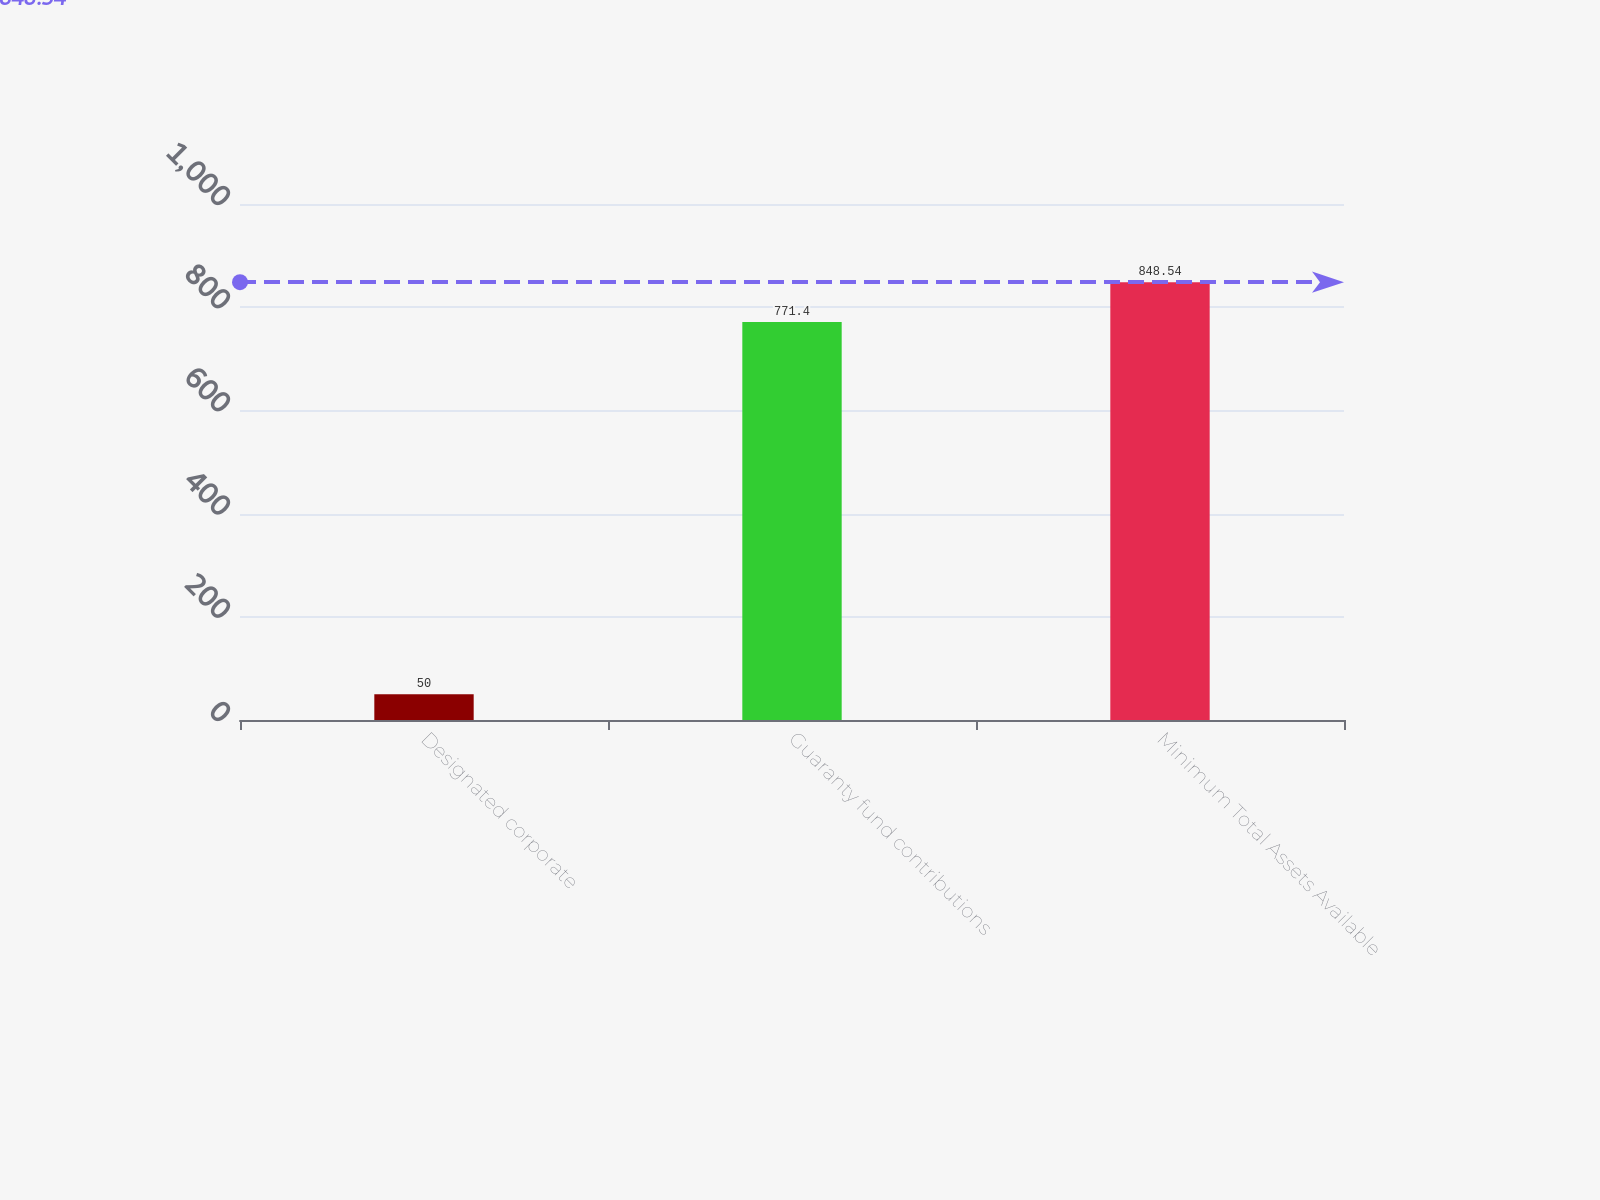Convert chart. <chart><loc_0><loc_0><loc_500><loc_500><bar_chart><fcel>Designated corporate<fcel>Guaranty fund contributions<fcel>Minimum Total Assets Available<nl><fcel>50<fcel>771.4<fcel>848.54<nl></chart> 